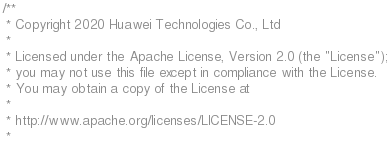<code> <loc_0><loc_0><loc_500><loc_500><_Cuda_>/**
 * Copyright 2020 Huawei Technologies Co., Ltd
 *
 * Licensed under the Apache License, Version 2.0 (the "License");
 * you may not use this file except in compliance with the License.
 * You may obtain a copy of the License at
 *
 * http://www.apache.org/licenses/LICENSE-2.0
 *</code> 